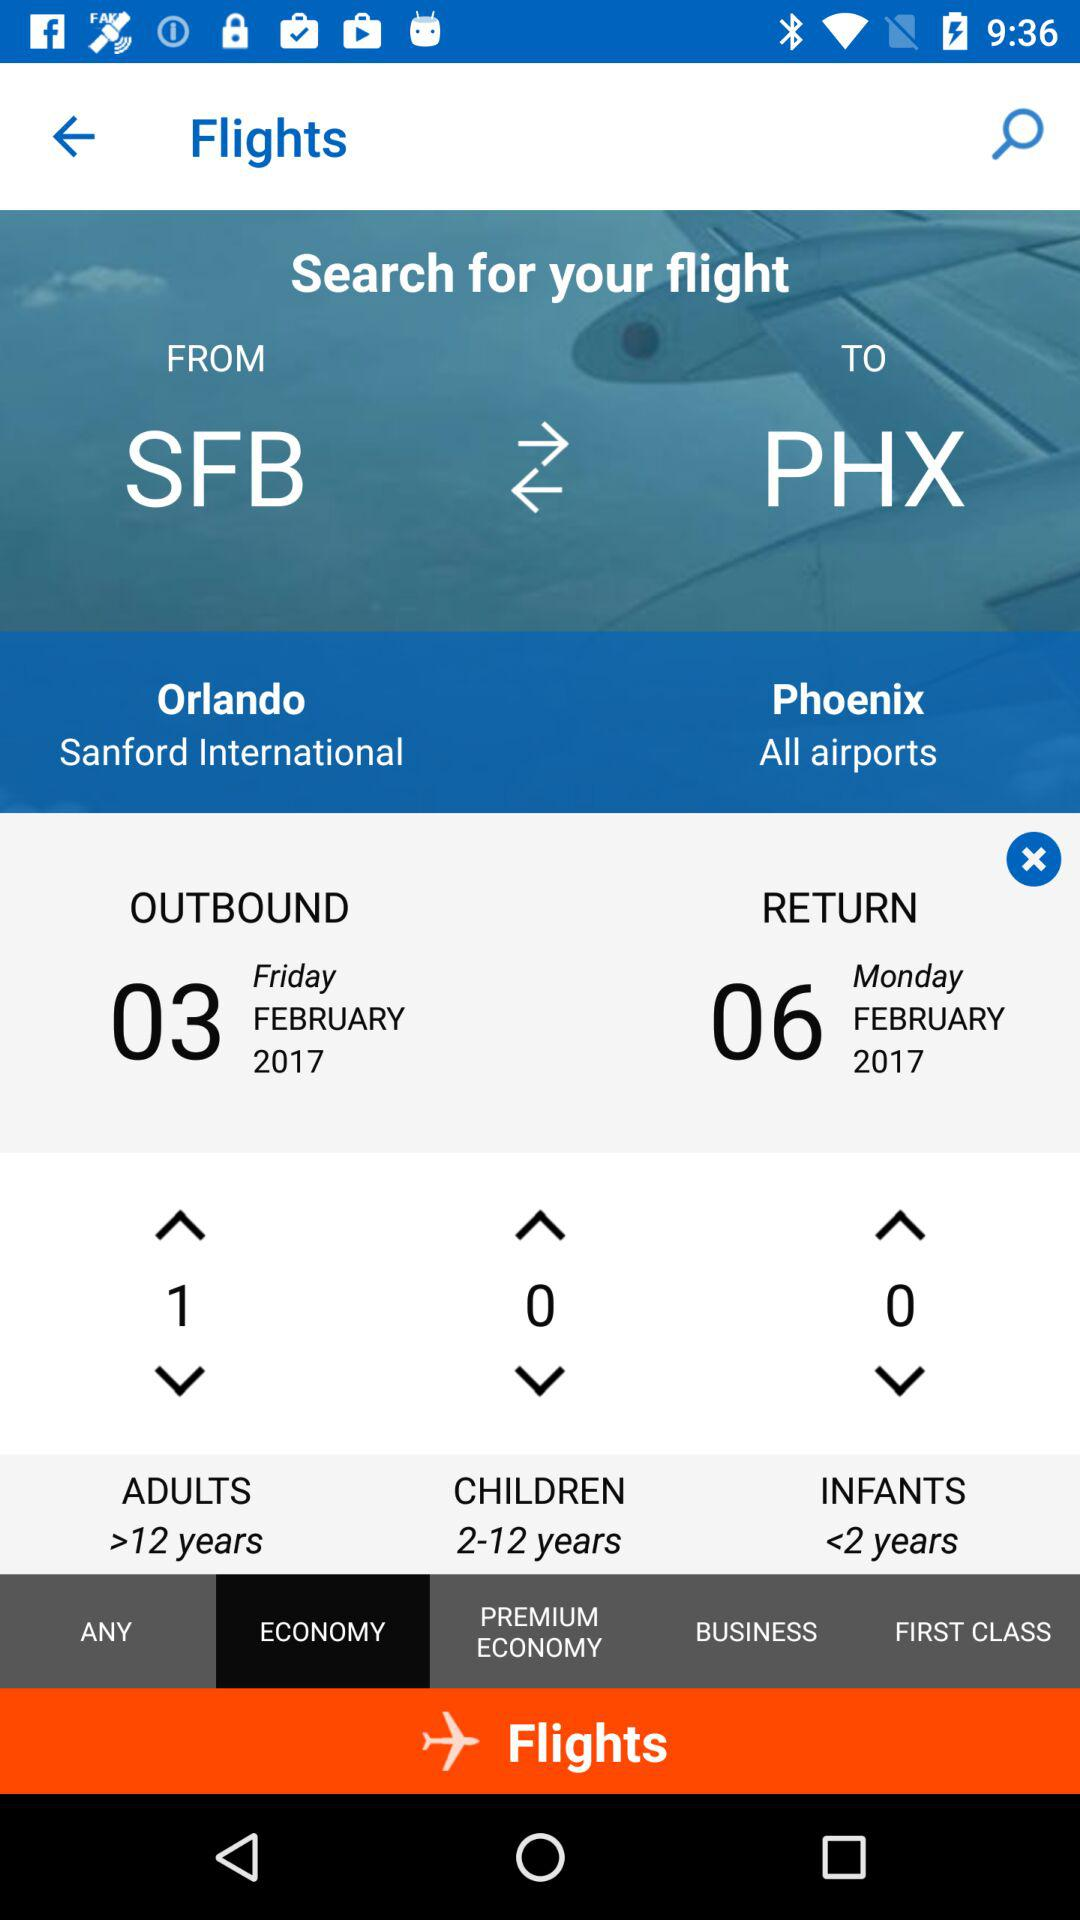What is the outbound date? The outbound date is Friday, February 3, 2017. 